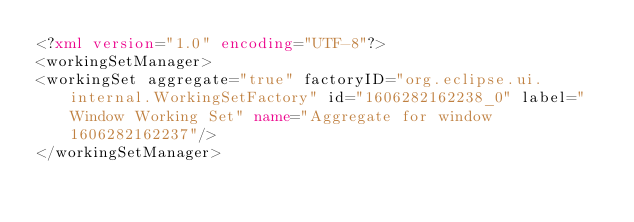<code> <loc_0><loc_0><loc_500><loc_500><_XML_><?xml version="1.0" encoding="UTF-8"?>
<workingSetManager>
<workingSet aggregate="true" factoryID="org.eclipse.ui.internal.WorkingSetFactory" id="1606282162238_0" label="Window Working Set" name="Aggregate for window 1606282162237"/>
</workingSetManager></code> 